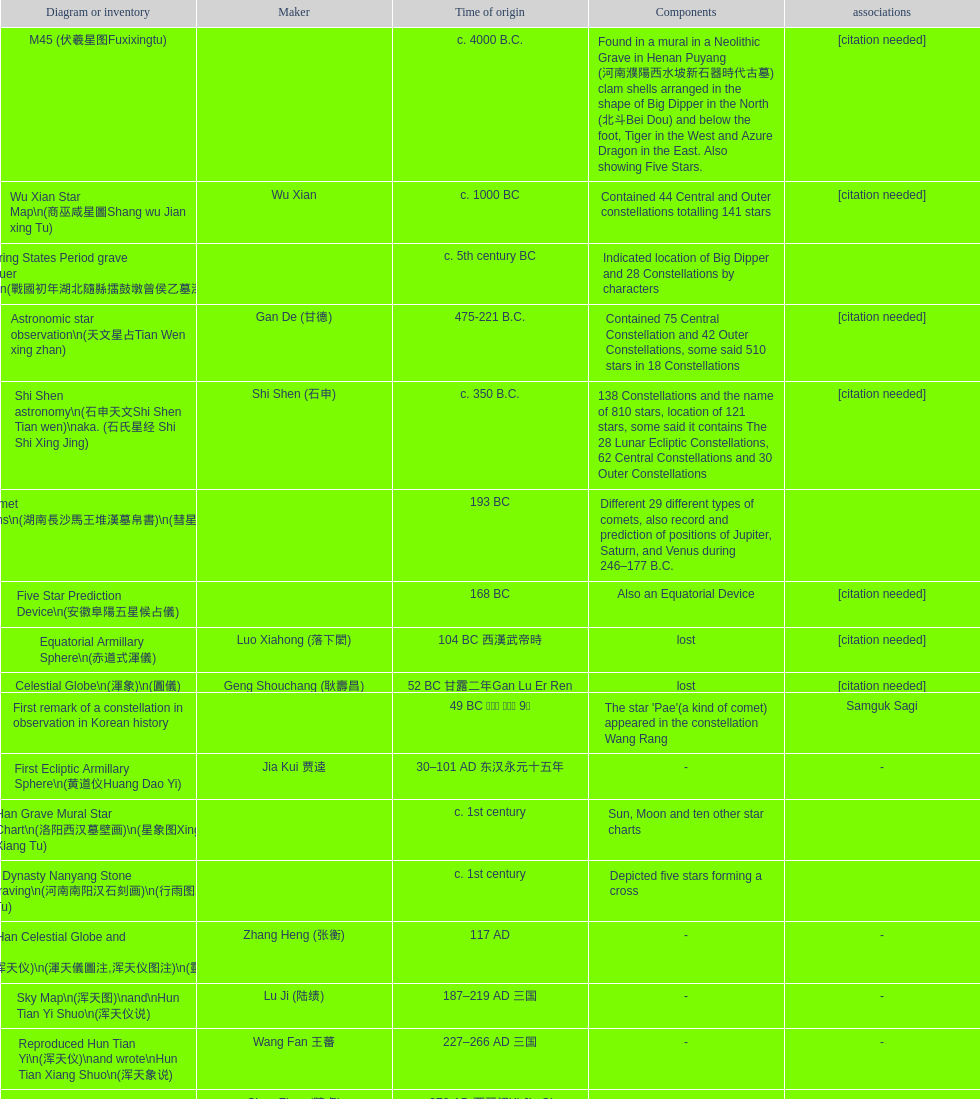What is the difference between the five star prediction device's date of creation and the han comet diagrams' date of creation? 25 years. 